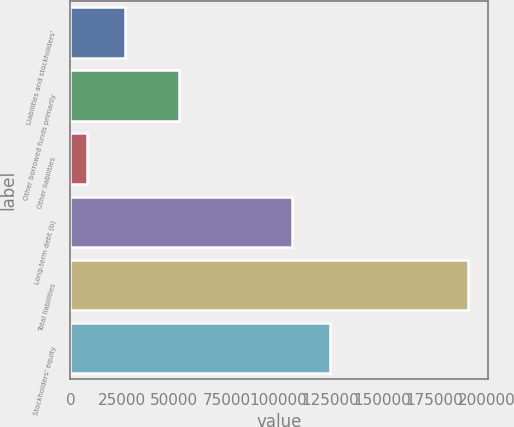Convert chart. <chart><loc_0><loc_0><loc_500><loc_500><bar_chart><fcel>Liabilities and stockholders'<fcel>Other borrowed funds primarily<fcel>Other liabilities<fcel>Long-term debt (b)<fcel>Total liabilities<fcel>Stockholders' equity<nl><fcel>26338.9<fcel>52440<fcel>8043<fcel>106581<fcel>191002<fcel>124877<nl></chart> 